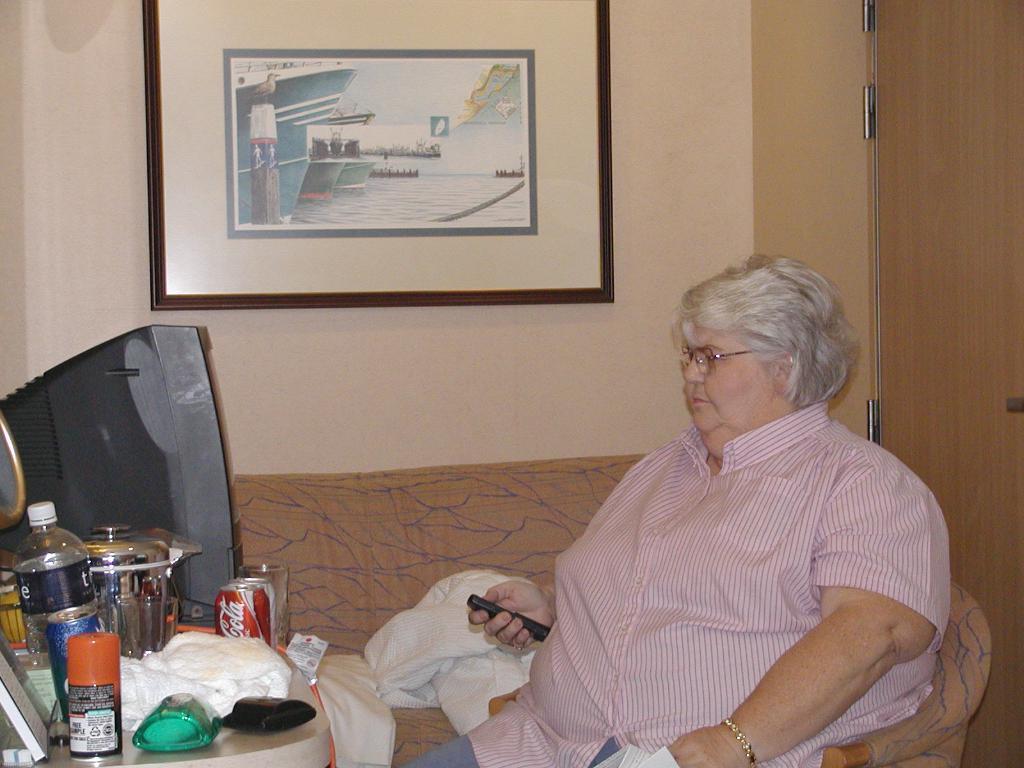In one or two sentences, can you explain what this image depicts? In the center of the image we can see a person is sitting on the chair and the person is holding an object. In front of a person, there is a table. On the table, we can see one monitor, one water bottle, cans and a few other objects. In the background, there is a wall, frame, couch, door and microfiber cloths. 